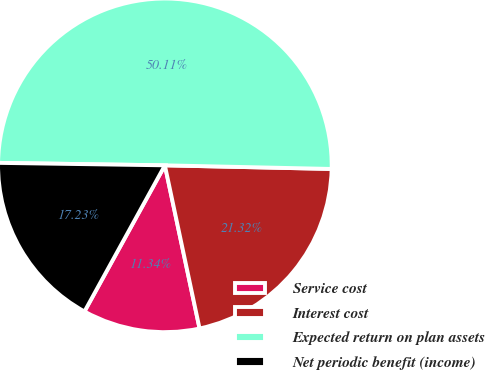Convert chart to OTSL. <chart><loc_0><loc_0><loc_500><loc_500><pie_chart><fcel>Service cost<fcel>Interest cost<fcel>Expected return on plan assets<fcel>Net periodic benefit (income)<nl><fcel>11.34%<fcel>21.32%<fcel>50.11%<fcel>17.23%<nl></chart> 